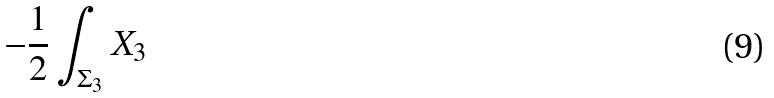<formula> <loc_0><loc_0><loc_500><loc_500>- \frac { 1 } { 2 } \int _ { \Sigma _ { 3 } } X _ { 3 }</formula> 